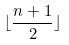Convert formula to latex. <formula><loc_0><loc_0><loc_500><loc_500>\lfloor \frac { n + 1 } { 2 } \rfloor</formula> 